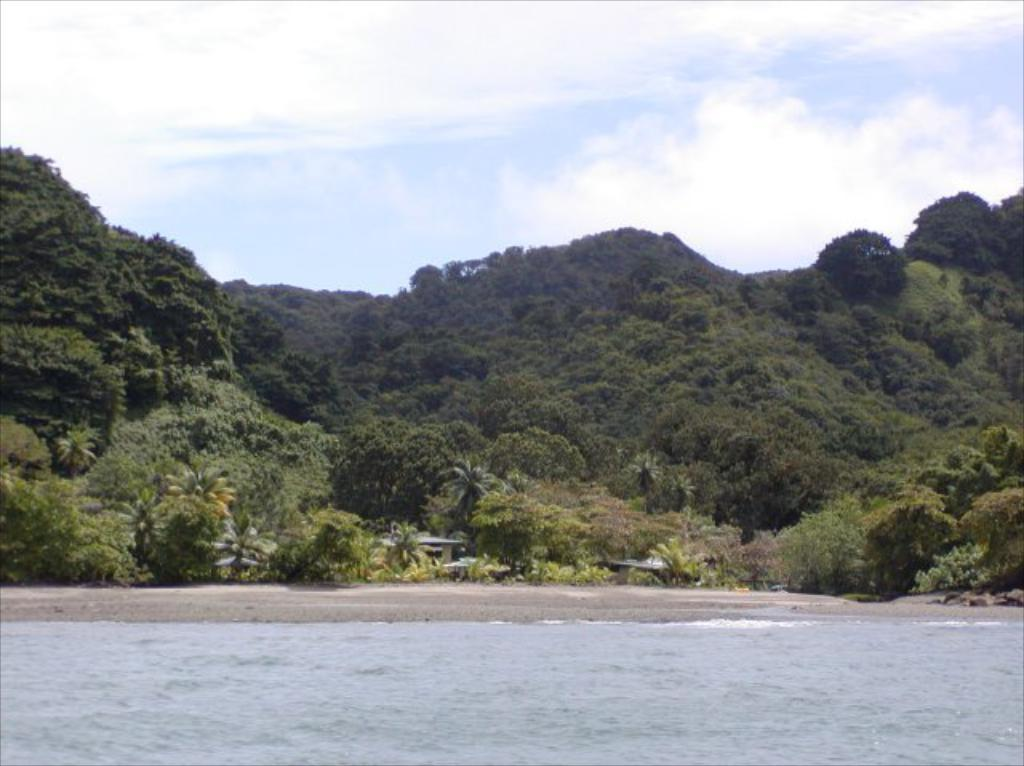Where was the image taken? The image was clicked outside. What can be seen in the foreground of the image? There is a water body in the foreground of the image. What is visible in the background of the image? The sky, hills, trees, plants, and other unspecified items are visible in the background of the image. What type of skate is being used by the person in the image? There is no person or skate present in the image. Where is the mailbox located in the image? There is no mailbox present in the image. 